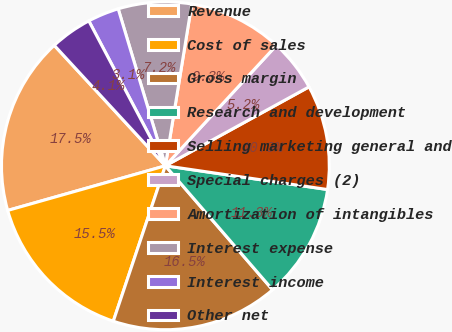Convert chart to OTSL. <chart><loc_0><loc_0><loc_500><loc_500><pie_chart><fcel>Revenue<fcel>Cost of sales<fcel>Gross margin<fcel>Research and development<fcel>Selling marketing general and<fcel>Special charges (2)<fcel>Amortization of intangibles<fcel>Interest expense<fcel>Interest income<fcel>Other net<nl><fcel>17.53%<fcel>15.46%<fcel>16.49%<fcel>11.34%<fcel>10.31%<fcel>5.15%<fcel>9.28%<fcel>7.22%<fcel>3.09%<fcel>4.12%<nl></chart> 